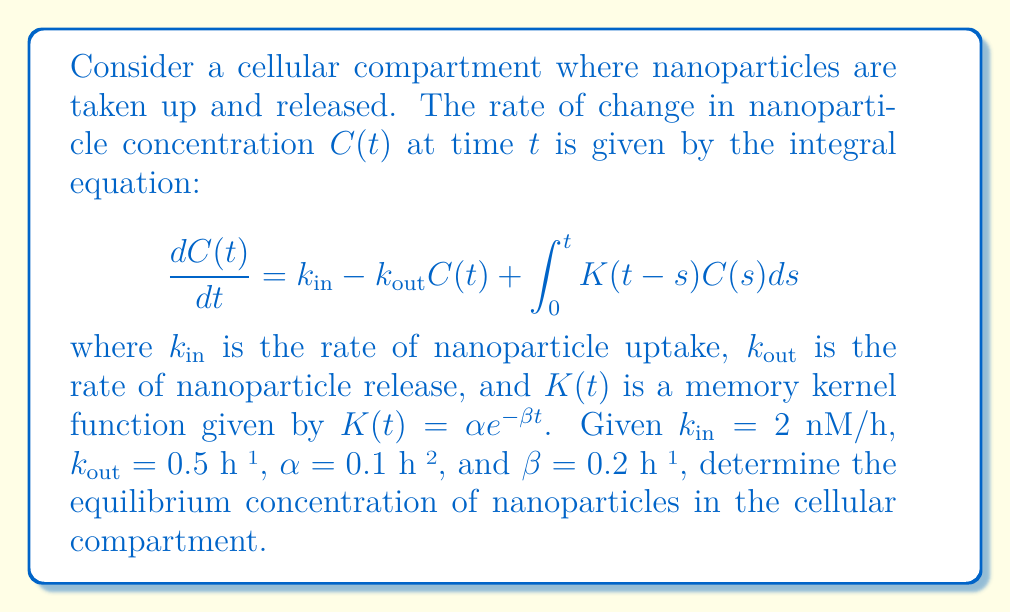Give your solution to this math problem. To solve this problem, we need to follow these steps:

1) At equilibrium, the concentration doesn't change with time, so $\frac{dC(t)}{dt} = 0$. Let's denote the equilibrium concentration as $C_{\text{eq}}$.

2) The integral equation at equilibrium becomes:

   $$0 = k_{\text{in}} - k_{\text{out}}C_{\text{eq}} + \int_0^{\infty} K(t-s)C_{\text{eq}}ds$$

3) Since $C_{\text{eq}}$ is constant, we can take it out of the integral:

   $$0 = k_{\text{in}} - k_{\text{out}}C_{\text{eq}} + C_{\text{eq}}\int_0^{\infty} K(t-s)ds$$

4) The integral of the memory kernel from 0 to infinity is:

   $$\int_0^{\infty} K(t-s)ds = \int_0^{\infty} \alpha e^{-\beta (t-s)}ds = \frac{\alpha}{\beta}$$

5) Substituting this back into the equation:

   $$0 = k_{\text{in}} - k_{\text{out}}C_{\text{eq}} + C_{\text{eq}}\frac{\alpha}{\beta}$$

6) Rearranging to solve for $C_{\text{eq}}$:

   $$C_{\text{eq}}(k_{\text{out}} - \frac{\alpha}{\beta}) = k_{\text{in}}$$

   $$C_{\text{eq}} = \frac{k_{\text{in}}}{k_{\text{out}} - \frac{\alpha}{\beta}}$$

7) Now we can substitute the given values:
   
   $$C_{\text{eq}} = \frac{2}{0.5 - \frac{0.1}{0.2}} = \frac{2}{0.5 - 0.5} = \frac{2}{0} = \infty$$

8) This result indicates that the system doesn't reach a finite equilibrium concentration. The uptake rate exceeds the combined effects of release and memory-dependent processes, leading to an unbounded increase in nanoparticle concentration over time.
Answer: The system does not reach a finite equilibrium concentration. 